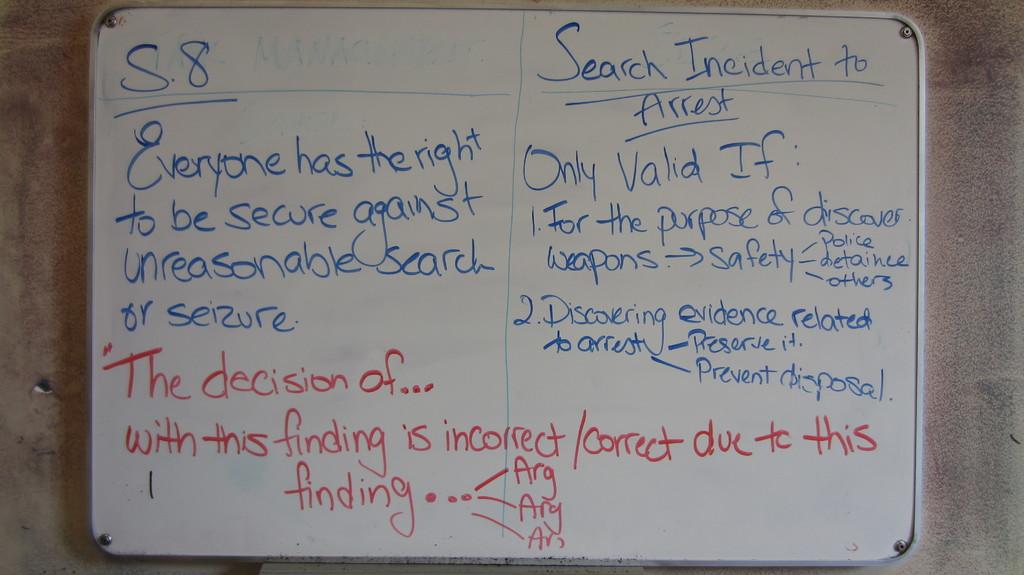What color ink are the letters in ?
Offer a terse response. Blue and red. What is the subject of the text on the right?
Your response must be concise. Search incident to arrest. 